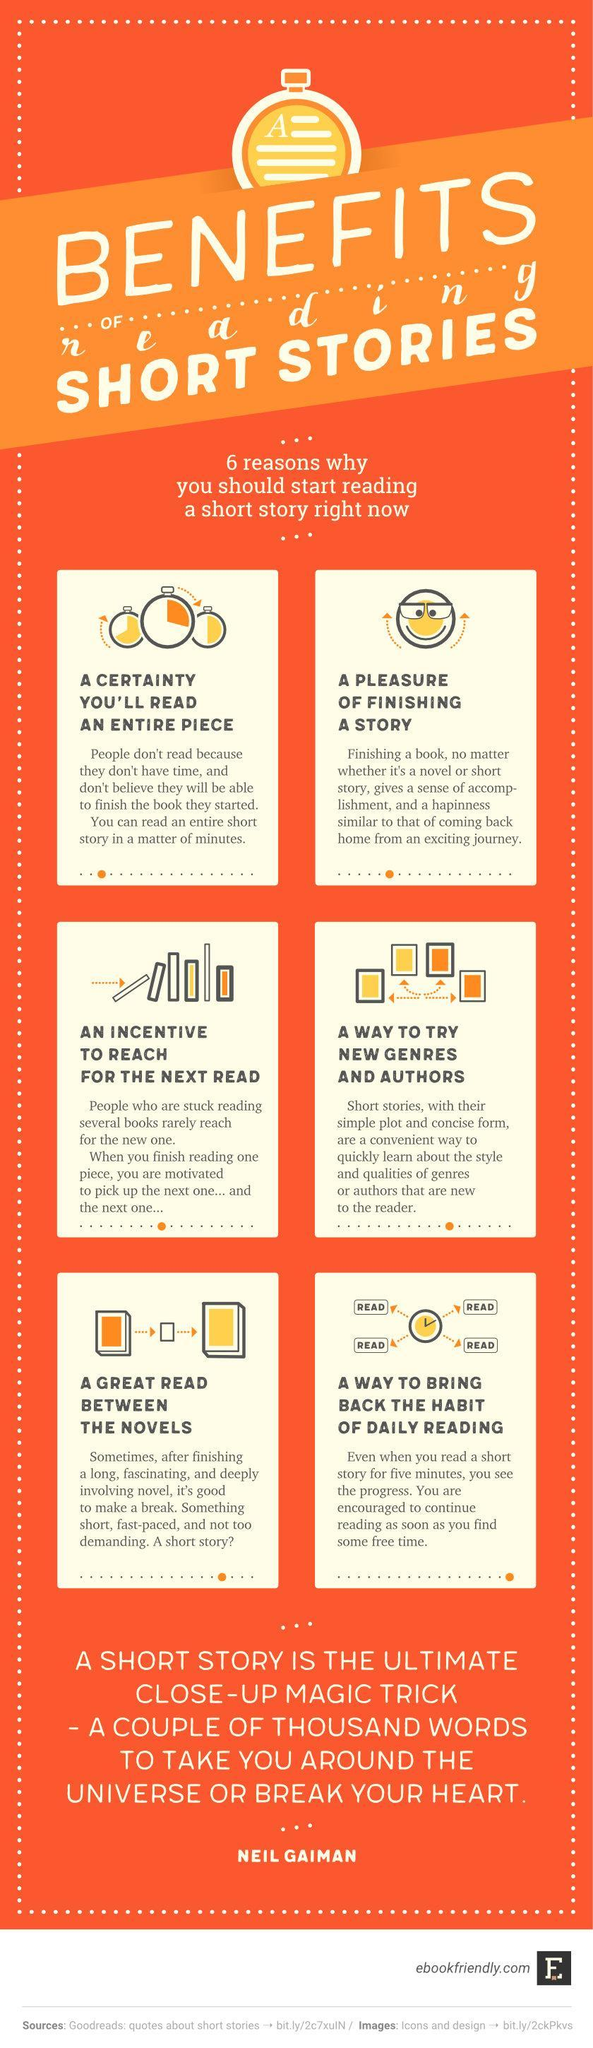What is the fifth benefit of reading short stories?
Answer the question with a short phrase. A great read between the novels What is the third benefit of reading short stories? An Incentive to reach for the next read What is the fourth benefit of reading short stories? A way to try new genres and authors 